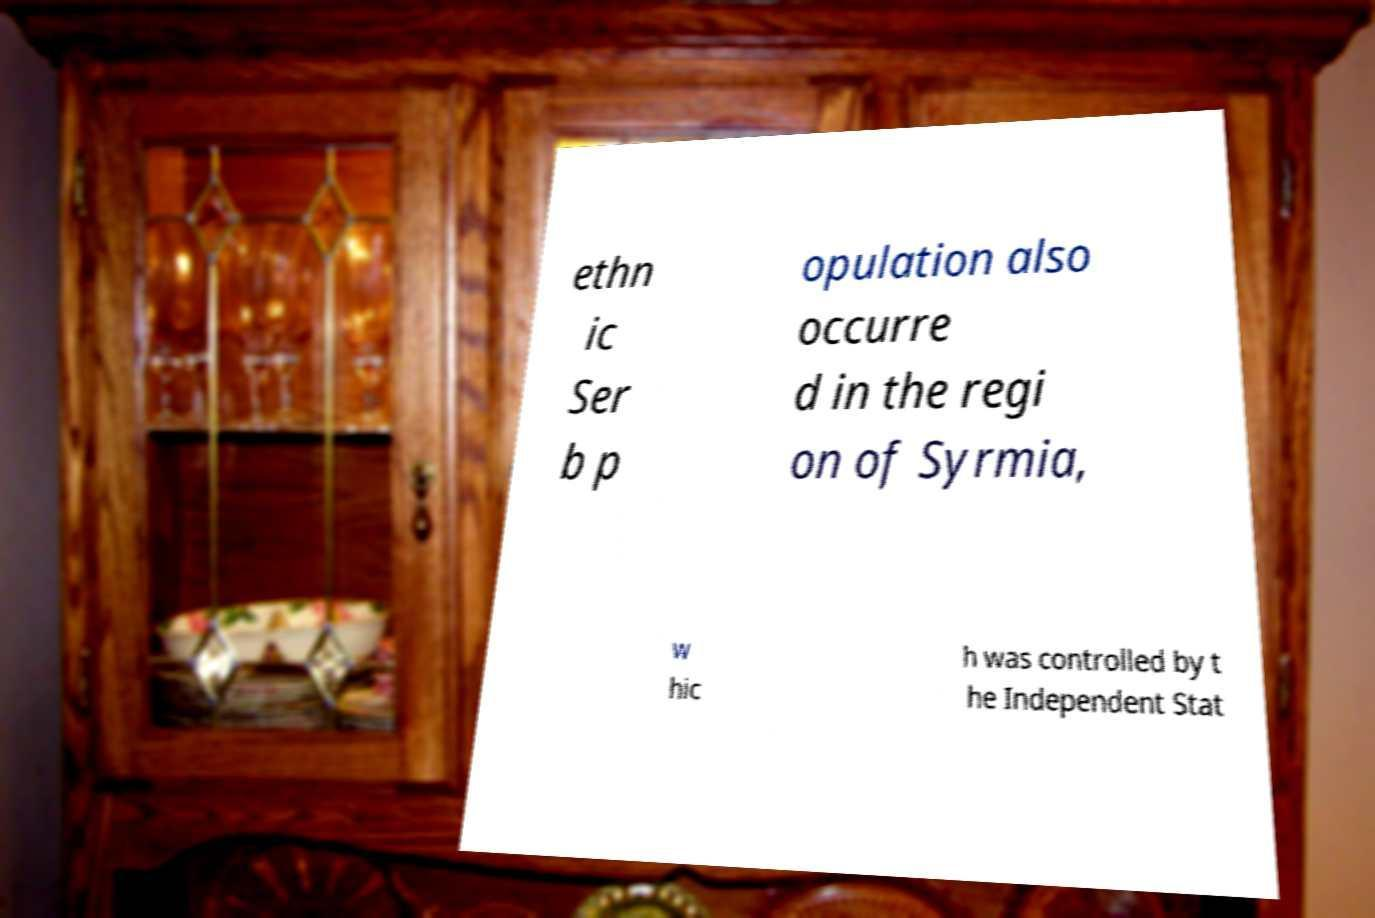Can you read and provide the text displayed in the image?This photo seems to have some interesting text. Can you extract and type it out for me? ethn ic Ser b p opulation also occurre d in the regi on of Syrmia, w hic h was controlled by t he Independent Stat 